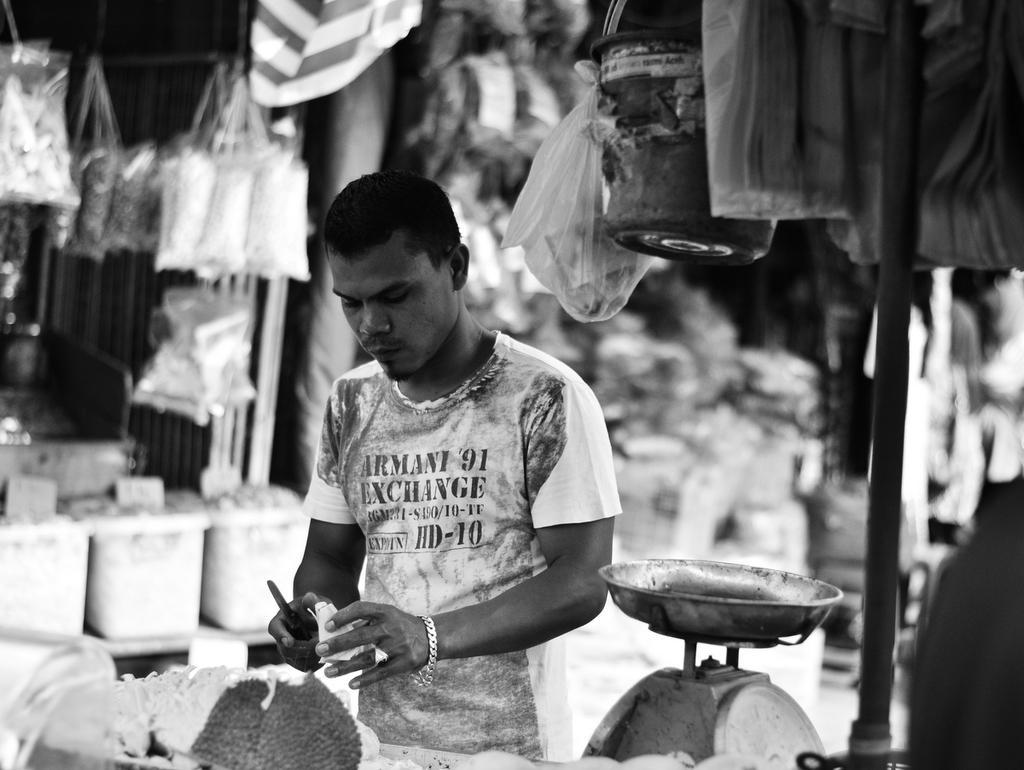How would you summarize this image in a sentence or two? This is a black and white picture, there is a man in the middle cutting a fruit and on the right side there is a weighing machine, in the background there are some stores. 